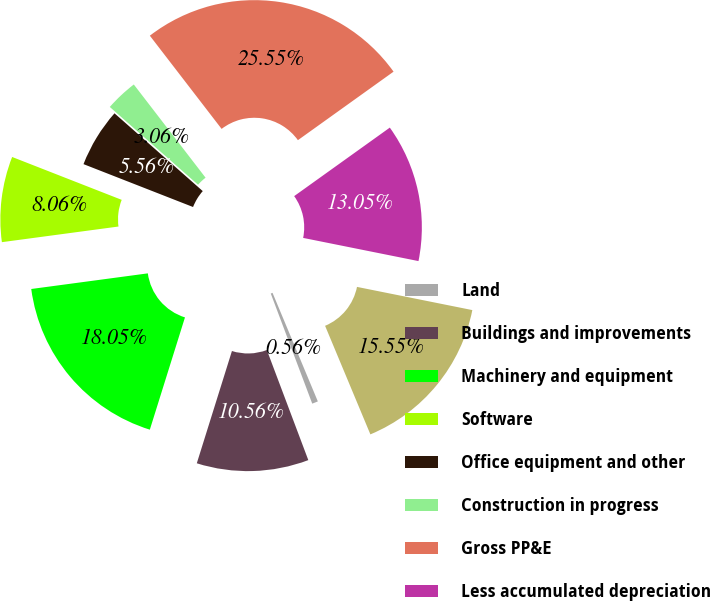<chart> <loc_0><loc_0><loc_500><loc_500><pie_chart><fcel>Land<fcel>Buildings and improvements<fcel>Machinery and equipment<fcel>Software<fcel>Office equipment and other<fcel>Construction in progress<fcel>Gross PP&E<fcel>Less accumulated depreciation<fcel>Net PP&E<nl><fcel>0.56%<fcel>10.56%<fcel>18.05%<fcel>8.06%<fcel>5.56%<fcel>3.06%<fcel>25.55%<fcel>13.05%<fcel>15.55%<nl></chart> 